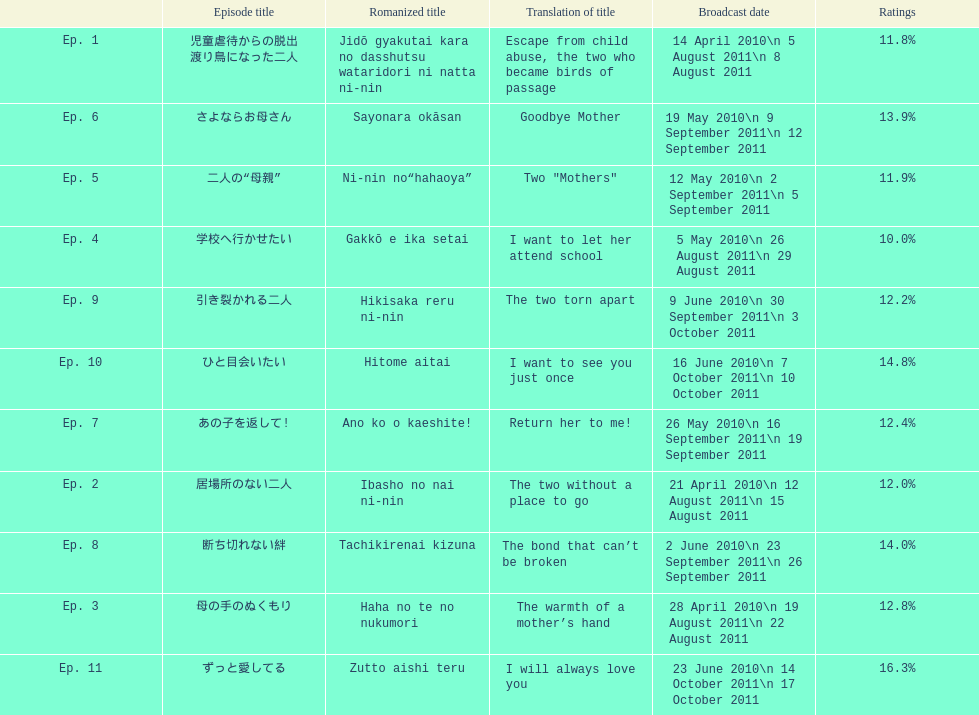Other than the 10th episode, which other episode has a 14% rating? Ep. 8. 